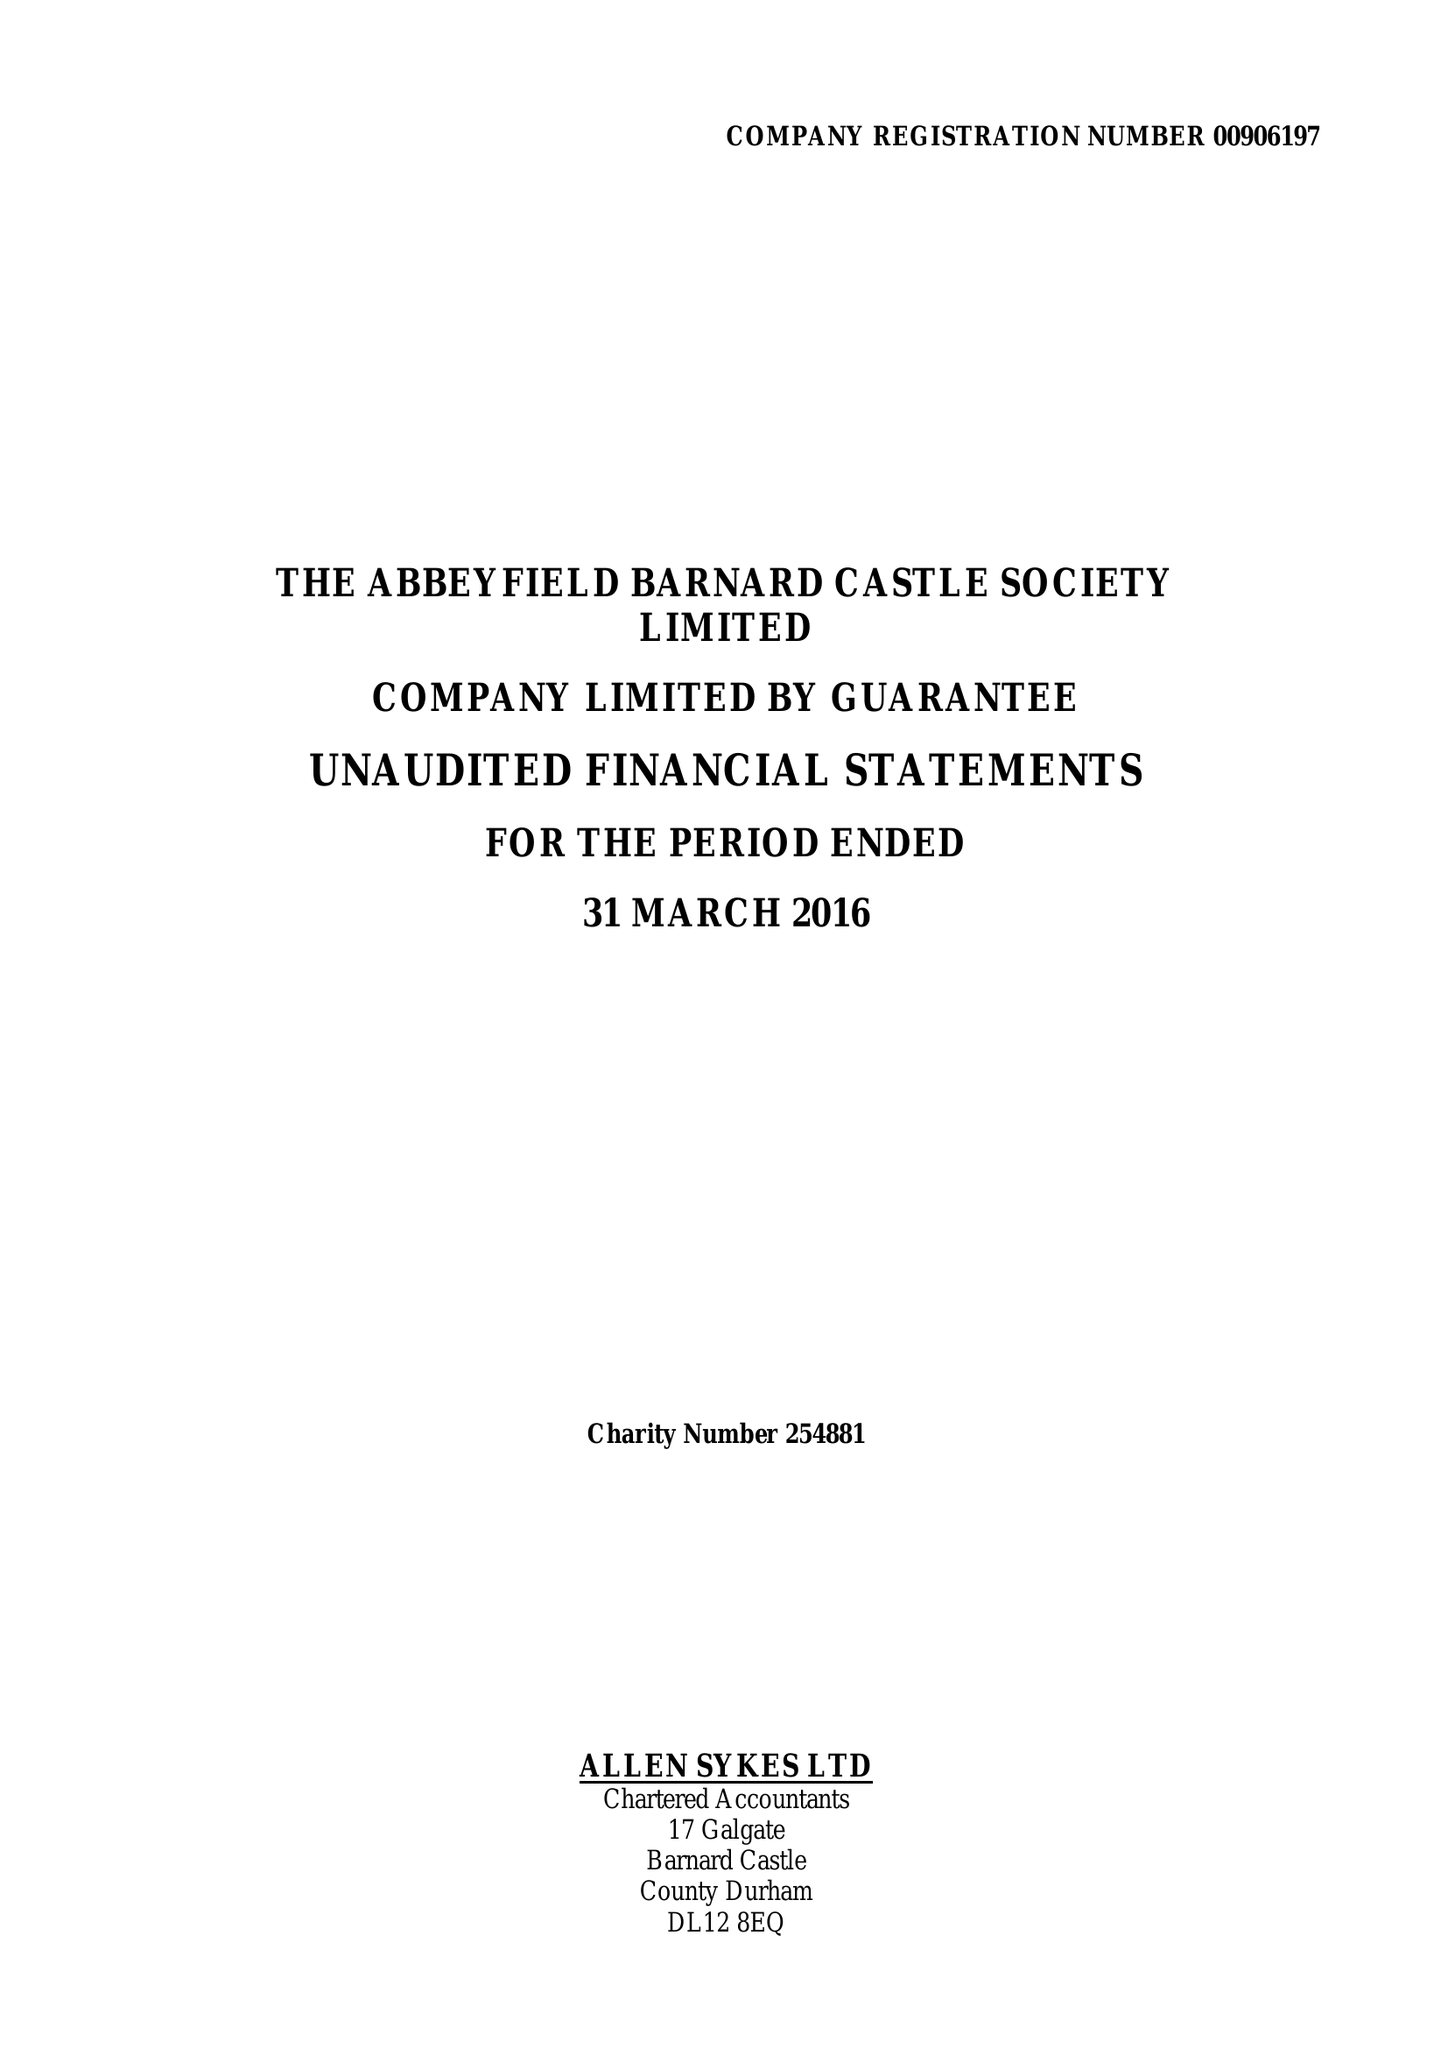What is the value for the charity_number?
Answer the question using a single word or phrase. 254881 